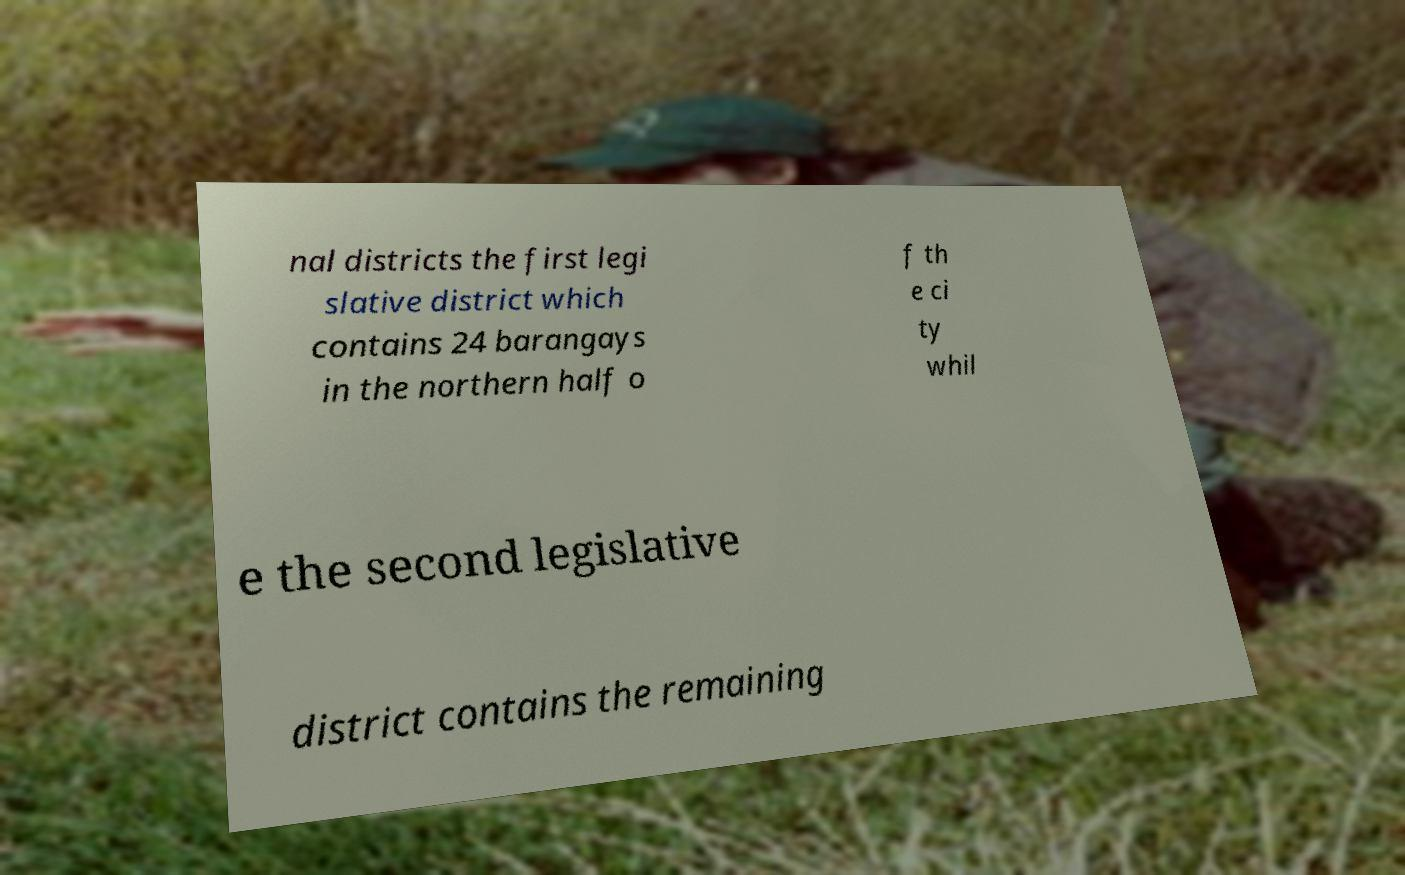For documentation purposes, I need the text within this image transcribed. Could you provide that? nal districts the first legi slative district which contains 24 barangays in the northern half o f th e ci ty whil e the second legislative district contains the remaining 